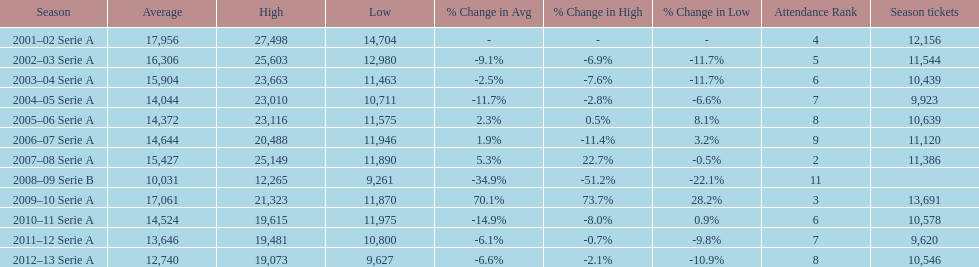What was the number of season tickets in 2007? 11,386. 